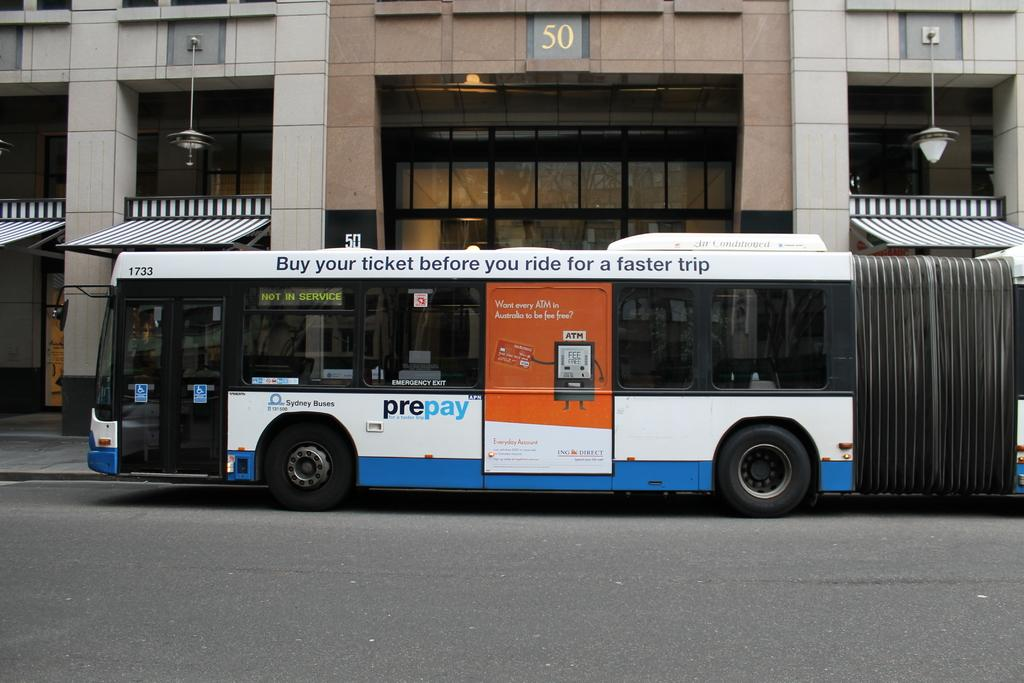Provide a one-sentence caption for the provided image. A long bus advertises to buy your ticket before you ride for a faster trip along its top. 